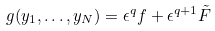Convert formula to latex. <formula><loc_0><loc_0><loc_500><loc_500>g ( y _ { 1 } , \dots , y _ { N } ) = \epsilon ^ { q } f + \epsilon ^ { q + 1 } \tilde { F }</formula> 